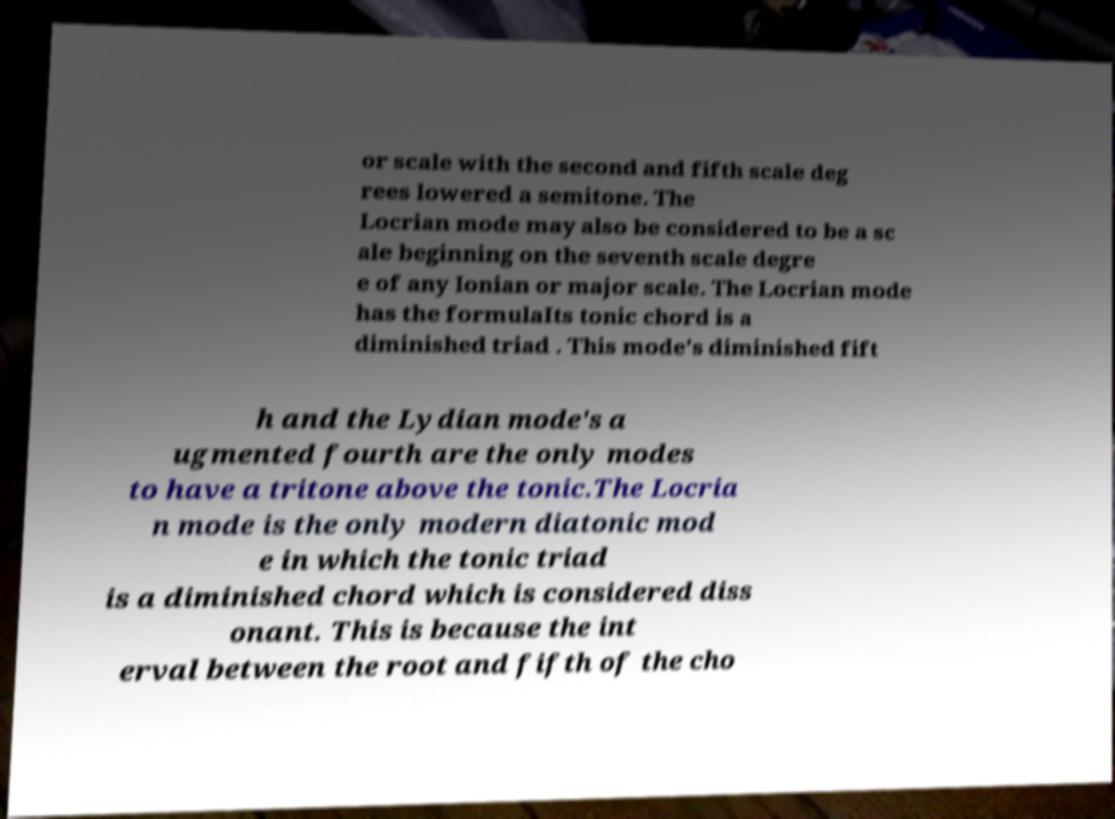Could you extract and type out the text from this image? or scale with the second and fifth scale deg rees lowered a semitone. The Locrian mode may also be considered to be a sc ale beginning on the seventh scale degre e of any Ionian or major scale. The Locrian mode has the formulaIts tonic chord is a diminished triad . This mode's diminished fift h and the Lydian mode's a ugmented fourth are the only modes to have a tritone above the tonic.The Locria n mode is the only modern diatonic mod e in which the tonic triad is a diminished chord which is considered diss onant. This is because the int erval between the root and fifth of the cho 